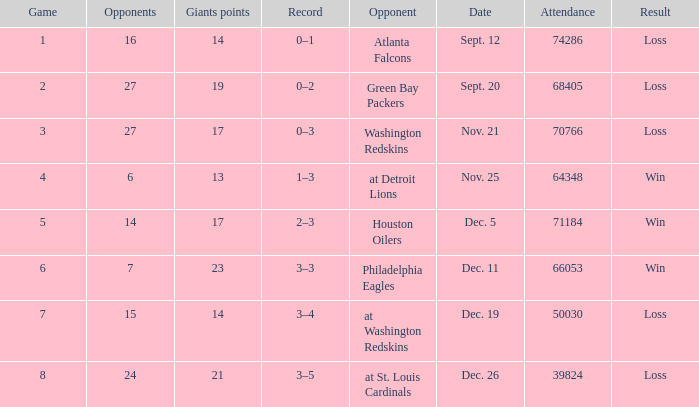What is the minimum number of opponents? 6.0. 